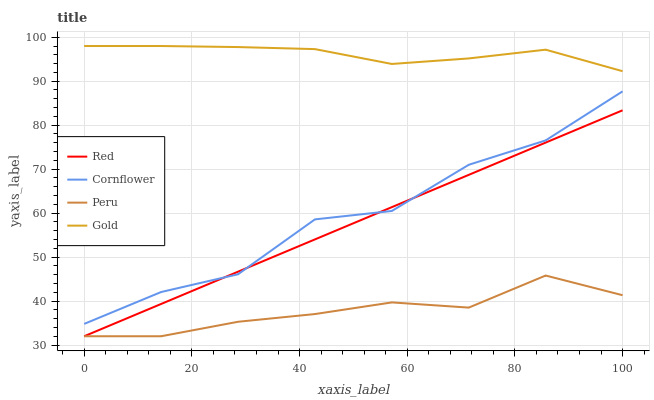Does Peru have the minimum area under the curve?
Answer yes or no. Yes. Does Gold have the maximum area under the curve?
Answer yes or no. Yes. Does Gold have the minimum area under the curve?
Answer yes or no. No. Does Peru have the maximum area under the curve?
Answer yes or no. No. Is Red the smoothest?
Answer yes or no. Yes. Is Cornflower the roughest?
Answer yes or no. Yes. Is Gold the smoothest?
Answer yes or no. No. Is Gold the roughest?
Answer yes or no. No. Does Peru have the lowest value?
Answer yes or no. Yes. Does Gold have the lowest value?
Answer yes or no. No. Does Gold have the highest value?
Answer yes or no. Yes. Does Peru have the highest value?
Answer yes or no. No. Is Peru less than Cornflower?
Answer yes or no. Yes. Is Gold greater than Peru?
Answer yes or no. Yes. Does Red intersect Cornflower?
Answer yes or no. Yes. Is Red less than Cornflower?
Answer yes or no. No. Is Red greater than Cornflower?
Answer yes or no. No. Does Peru intersect Cornflower?
Answer yes or no. No. 